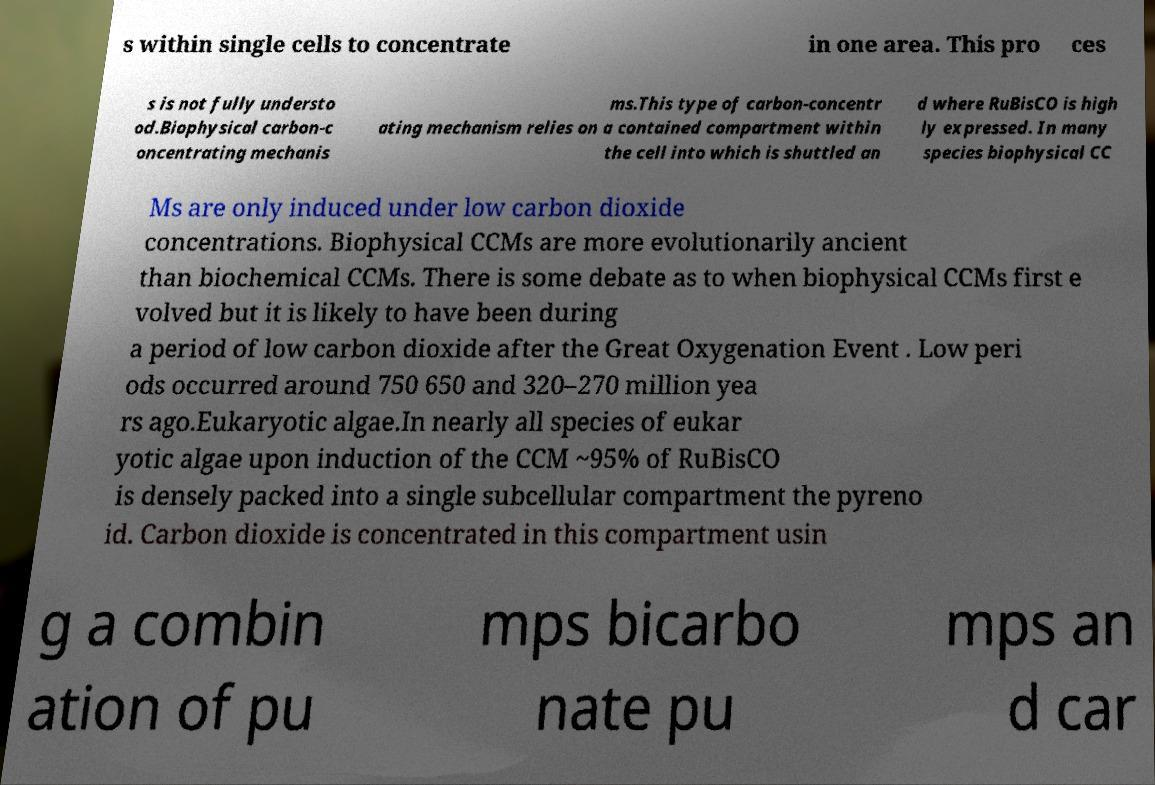There's text embedded in this image that I need extracted. Can you transcribe it verbatim? s within single cells to concentrate in one area. This pro ces s is not fully understo od.Biophysical carbon-c oncentrating mechanis ms.This type of carbon-concentr ating mechanism relies on a contained compartment within the cell into which is shuttled an d where RuBisCO is high ly expressed. In many species biophysical CC Ms are only induced under low carbon dioxide concentrations. Biophysical CCMs are more evolutionarily ancient than biochemical CCMs. There is some debate as to when biophysical CCMs first e volved but it is likely to have been during a period of low carbon dioxide after the Great Oxygenation Event . Low peri ods occurred around 750 650 and 320–270 million yea rs ago.Eukaryotic algae.In nearly all species of eukar yotic algae upon induction of the CCM ~95% of RuBisCO is densely packed into a single subcellular compartment the pyreno id. Carbon dioxide is concentrated in this compartment usin g a combin ation of pu mps bicarbo nate pu mps an d car 